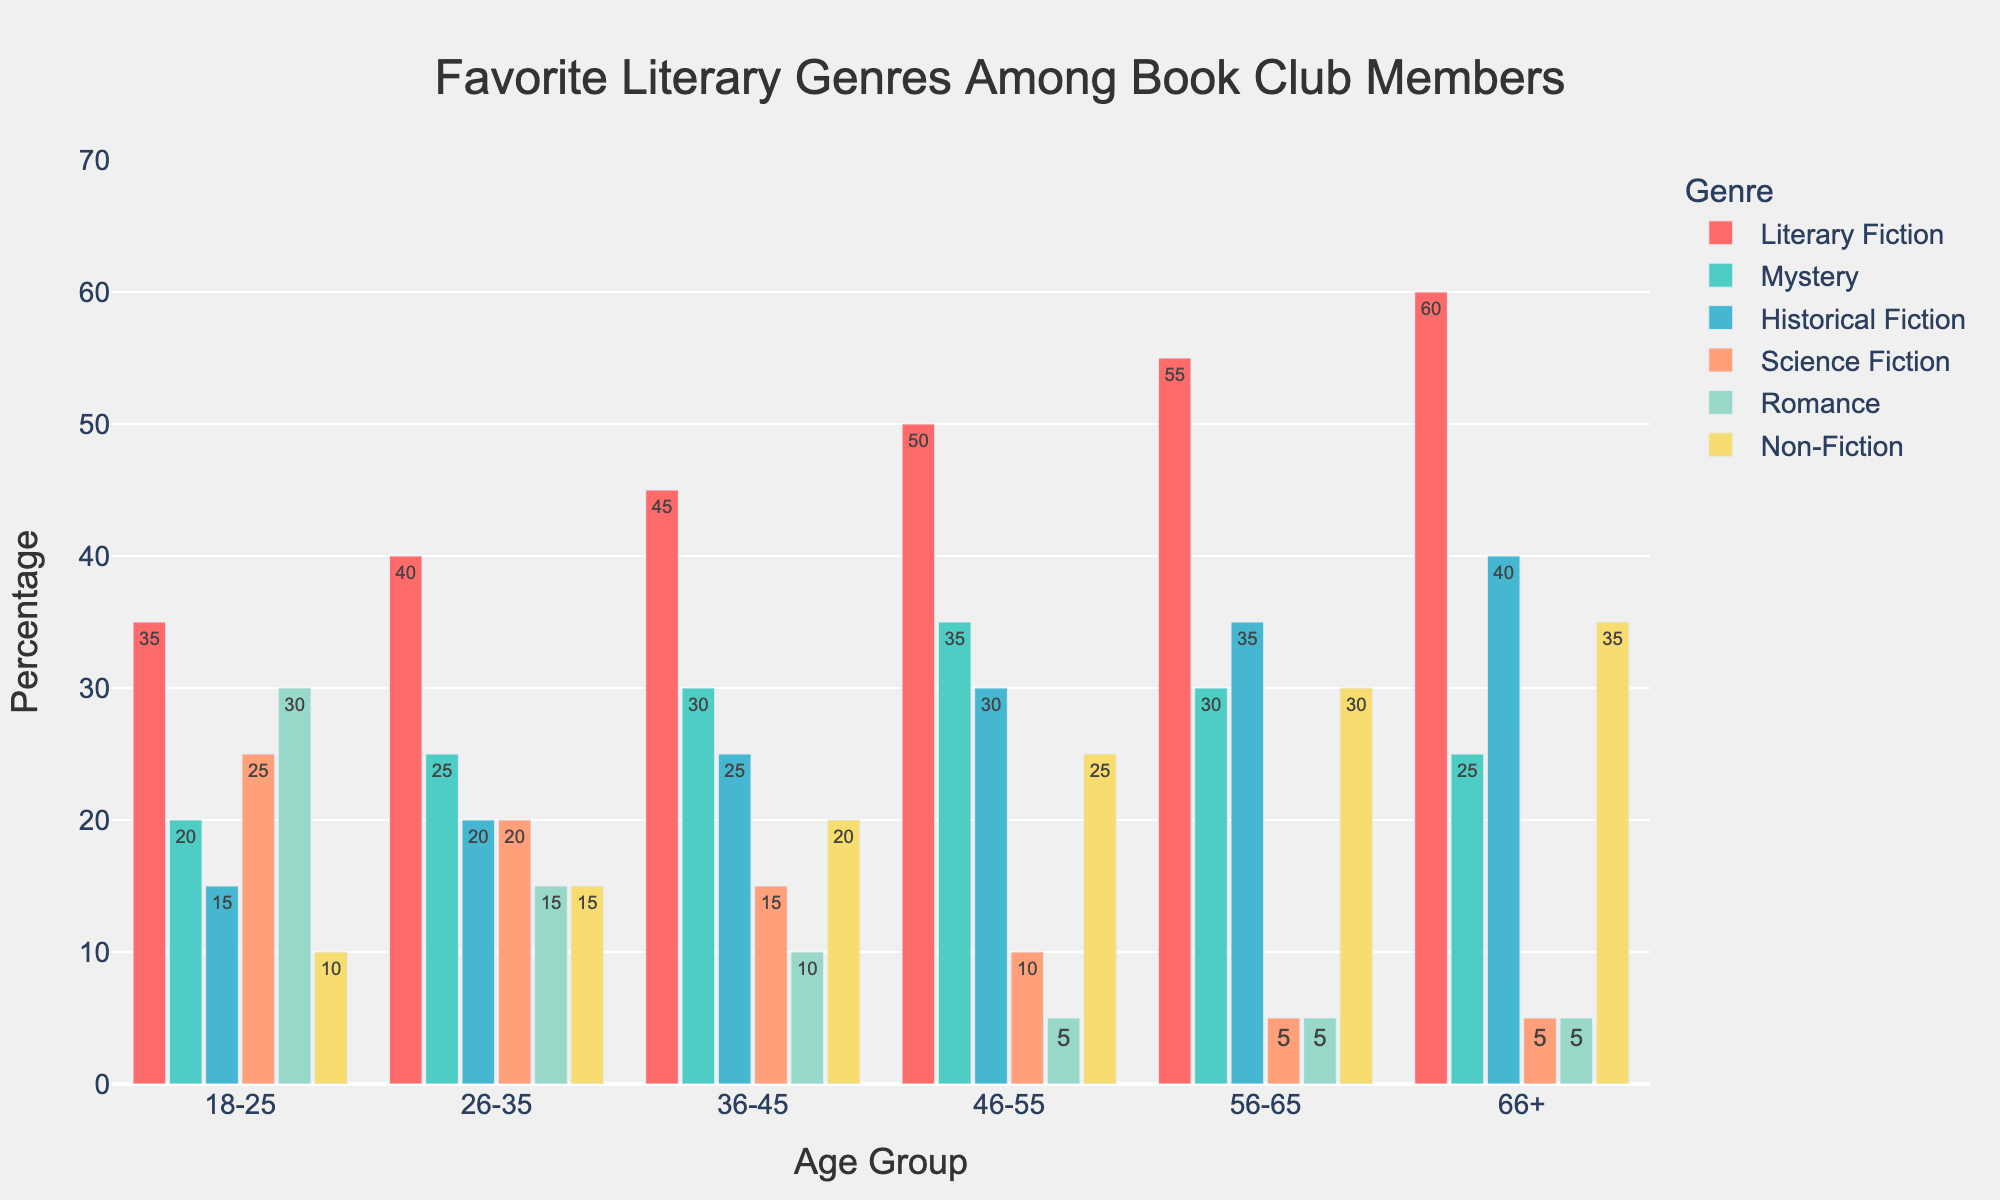What's the most popular genre for the 46-55 age group? Look at the bar heights for the 46-55 age group (blue bars). The tallest bar corresponds to Literary Fiction with a value of 50.
Answer: Literary Fiction Which age group prefers Science Fiction the least? Look at the heights of the orange bars representing Science Fiction across all age groups. The 56-65 and 66+ age groups have the smallest bars, both with a value of 5.
Answer: 56-65 and 66+ Compare the preferences for Mystery between the 18-25 and 26-35 age groups. Compare the heights of the green bars for these two age groups. The 18-25 group has a height of 20, and the 26-35 has a height of 25.
Answer: 26-35 prefers it more Which genre shows an increasing trend across all age groups? Observe all genres across the age groups and identify the trend. Literary Fiction shows an increasing height consistently from 18-25 to 66+.
Answer: Literary Fiction What is the total percentage of readers who prefer Non-Fiction across all age groups? Sum the values of Non-Fiction for all age groups: 10 + 15 + 20 + 25 + 30 + 35 = 135.
Answer: 135 Which age group has the least interest in Romance? Compare the heights of the pink bars for all age groups. The 46-55, 56-65, and 66+ groups have the shortest bars, each with a value of 5.
Answer: 46-55, 56-65, and 66+ How does the preference for Historical Fiction in the 26-35 group compare to that in the 36-45 group? Compare the heights of the purple bars. The 26-35 age group has a value of 20, while the 36-45 group has a value of 25.
Answer: 36-45 prefers it more Which genre is least popular among the 36-45 age group? Look at the bar heights for the 36-45 age group. The shortest bar corresponds to Romance with a value of 10.
Answer: Romance What is the average preference for Romance among all age groups? Add up all the Romance values and divide by the number of age groups: (30 + 15 + 10 + 5 + 5 + 5) / 6 = 70 / 6 ≈ 11.67.
Answer: ≈ 11.67 What is the combined preference for Literary Fiction and Non-Fiction among the 66+ group? Add the values for Literary Fiction and Non-Fiction in the 66+ group: 60 + 35 = 95.
Answer: 95 